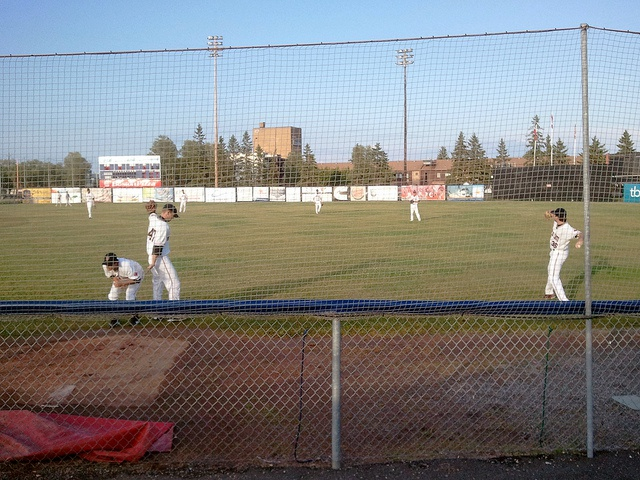Describe the objects in this image and their specific colors. I can see people in darkgray, lightgray, and gray tones, people in darkgray, lightgray, and gray tones, people in darkgray, lightgray, and gray tones, people in darkgray, white, tan, and lightpink tones, and people in darkgray, white, tan, and lightgray tones in this image. 